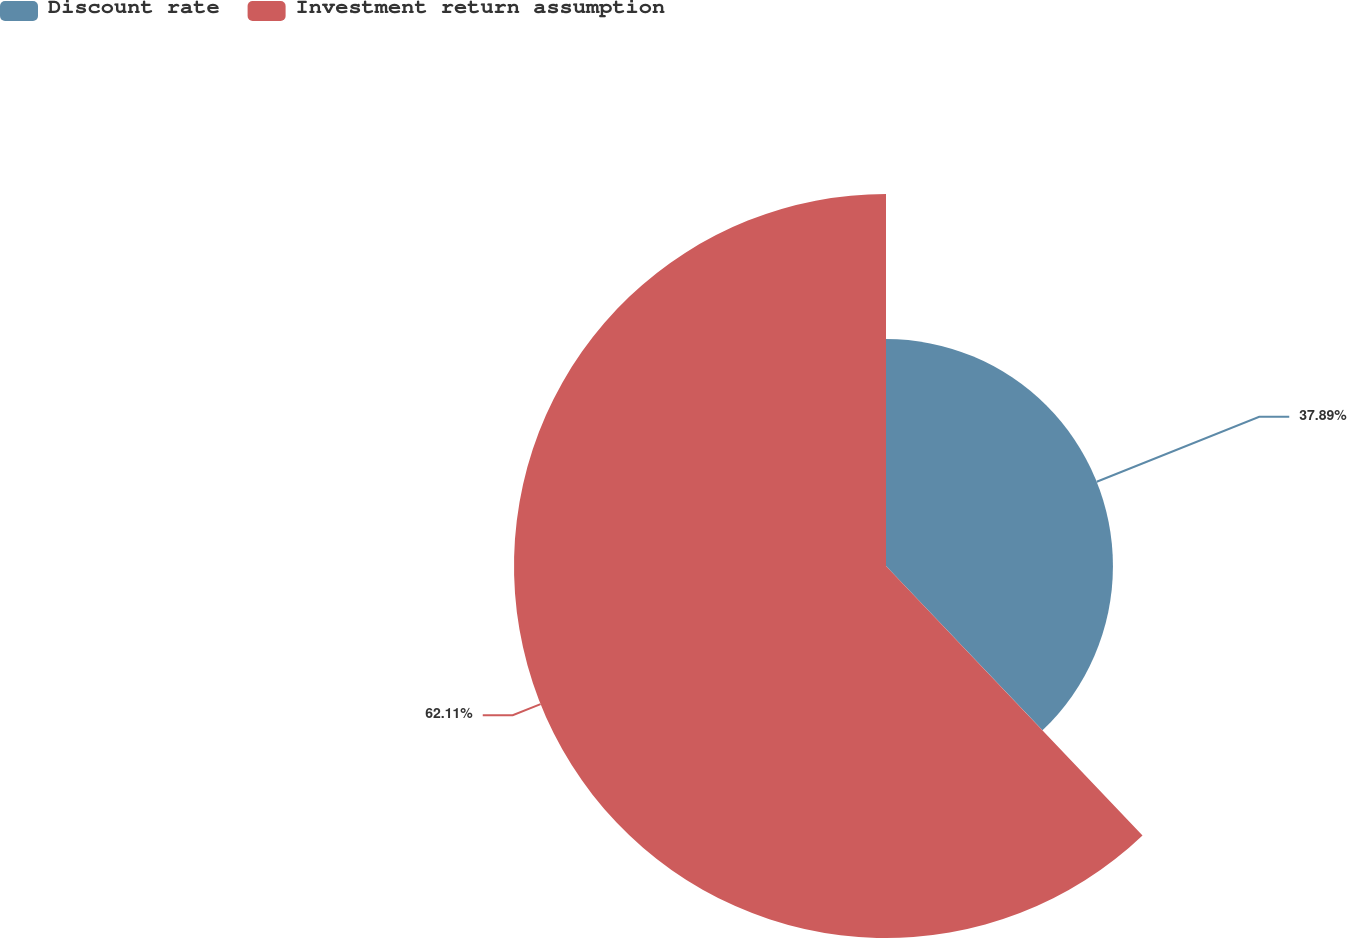Convert chart. <chart><loc_0><loc_0><loc_500><loc_500><pie_chart><fcel>Discount rate<fcel>Investment return assumption<nl><fcel>37.89%<fcel>62.11%<nl></chart> 